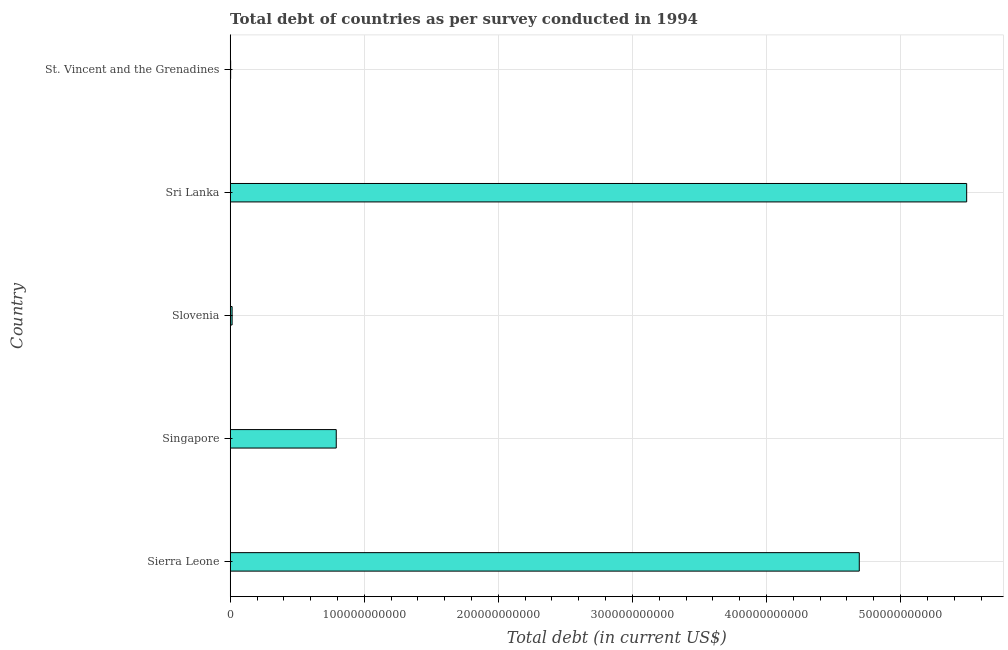Does the graph contain any zero values?
Your answer should be very brief. No. What is the title of the graph?
Offer a very short reply. Total debt of countries as per survey conducted in 1994. What is the label or title of the X-axis?
Provide a succinct answer. Total debt (in current US$). What is the total debt in Sierra Leone?
Your answer should be very brief. 4.69e+11. Across all countries, what is the maximum total debt?
Your answer should be very brief. 5.49e+11. Across all countries, what is the minimum total debt?
Your response must be concise. 3.38e+08. In which country was the total debt maximum?
Your answer should be compact. Sri Lanka. In which country was the total debt minimum?
Give a very brief answer. St. Vincent and the Grenadines. What is the sum of the total debt?
Offer a terse response. 1.10e+12. What is the difference between the total debt in Sierra Leone and Singapore?
Give a very brief answer. 3.90e+11. What is the average total debt per country?
Your response must be concise. 2.20e+11. What is the median total debt?
Provide a succinct answer. 7.91e+1. In how many countries, is the total debt greater than 60000000000 US$?
Keep it short and to the point. 3. What is the ratio of the total debt in Sierra Leone to that in Singapore?
Your response must be concise. 5.93. Is the total debt in Slovenia less than that in Sri Lanka?
Your answer should be very brief. Yes. Is the difference between the total debt in Sierra Leone and Sri Lanka greater than the difference between any two countries?
Your answer should be compact. No. What is the difference between the highest and the second highest total debt?
Your answer should be compact. 8.01e+1. Is the sum of the total debt in Sierra Leone and St. Vincent and the Grenadines greater than the maximum total debt across all countries?
Your answer should be compact. No. What is the difference between the highest and the lowest total debt?
Give a very brief answer. 5.49e+11. In how many countries, is the total debt greater than the average total debt taken over all countries?
Your response must be concise. 2. Are all the bars in the graph horizontal?
Provide a succinct answer. Yes. What is the difference between two consecutive major ticks on the X-axis?
Make the answer very short. 1.00e+11. What is the Total debt (in current US$) of Sierra Leone?
Your answer should be very brief. 4.69e+11. What is the Total debt (in current US$) of Singapore?
Provide a short and direct response. 7.91e+1. What is the Total debt (in current US$) of Slovenia?
Offer a very short reply. 1.43e+09. What is the Total debt (in current US$) of Sri Lanka?
Offer a very short reply. 5.49e+11. What is the Total debt (in current US$) of St. Vincent and the Grenadines?
Offer a very short reply. 3.38e+08. What is the difference between the Total debt (in current US$) in Sierra Leone and Singapore?
Give a very brief answer. 3.90e+11. What is the difference between the Total debt (in current US$) in Sierra Leone and Slovenia?
Give a very brief answer. 4.68e+11. What is the difference between the Total debt (in current US$) in Sierra Leone and Sri Lanka?
Offer a very short reply. -8.01e+1. What is the difference between the Total debt (in current US$) in Sierra Leone and St. Vincent and the Grenadines?
Provide a succinct answer. 4.69e+11. What is the difference between the Total debt (in current US$) in Singapore and Slovenia?
Offer a terse response. 7.77e+1. What is the difference between the Total debt (in current US$) in Singapore and Sri Lanka?
Your answer should be compact. -4.70e+11. What is the difference between the Total debt (in current US$) in Singapore and St. Vincent and the Grenadines?
Your response must be concise. 7.88e+1. What is the difference between the Total debt (in current US$) in Slovenia and Sri Lanka?
Your answer should be very brief. -5.48e+11. What is the difference between the Total debt (in current US$) in Slovenia and St. Vincent and the Grenadines?
Give a very brief answer. 1.09e+09. What is the difference between the Total debt (in current US$) in Sri Lanka and St. Vincent and the Grenadines?
Your response must be concise. 5.49e+11. What is the ratio of the Total debt (in current US$) in Sierra Leone to that in Singapore?
Your answer should be very brief. 5.93. What is the ratio of the Total debt (in current US$) in Sierra Leone to that in Slovenia?
Your answer should be compact. 327.81. What is the ratio of the Total debt (in current US$) in Sierra Leone to that in Sri Lanka?
Provide a short and direct response. 0.85. What is the ratio of the Total debt (in current US$) in Sierra Leone to that in St. Vincent and the Grenadines?
Provide a succinct answer. 1387.77. What is the ratio of the Total debt (in current US$) in Singapore to that in Slovenia?
Provide a succinct answer. 55.27. What is the ratio of the Total debt (in current US$) in Singapore to that in Sri Lanka?
Your answer should be compact. 0.14. What is the ratio of the Total debt (in current US$) in Singapore to that in St. Vincent and the Grenadines?
Ensure brevity in your answer.  233.97. What is the ratio of the Total debt (in current US$) in Slovenia to that in Sri Lanka?
Offer a very short reply. 0. What is the ratio of the Total debt (in current US$) in Slovenia to that in St. Vincent and the Grenadines?
Offer a very short reply. 4.23. What is the ratio of the Total debt (in current US$) in Sri Lanka to that in St. Vincent and the Grenadines?
Provide a succinct answer. 1624.64. 